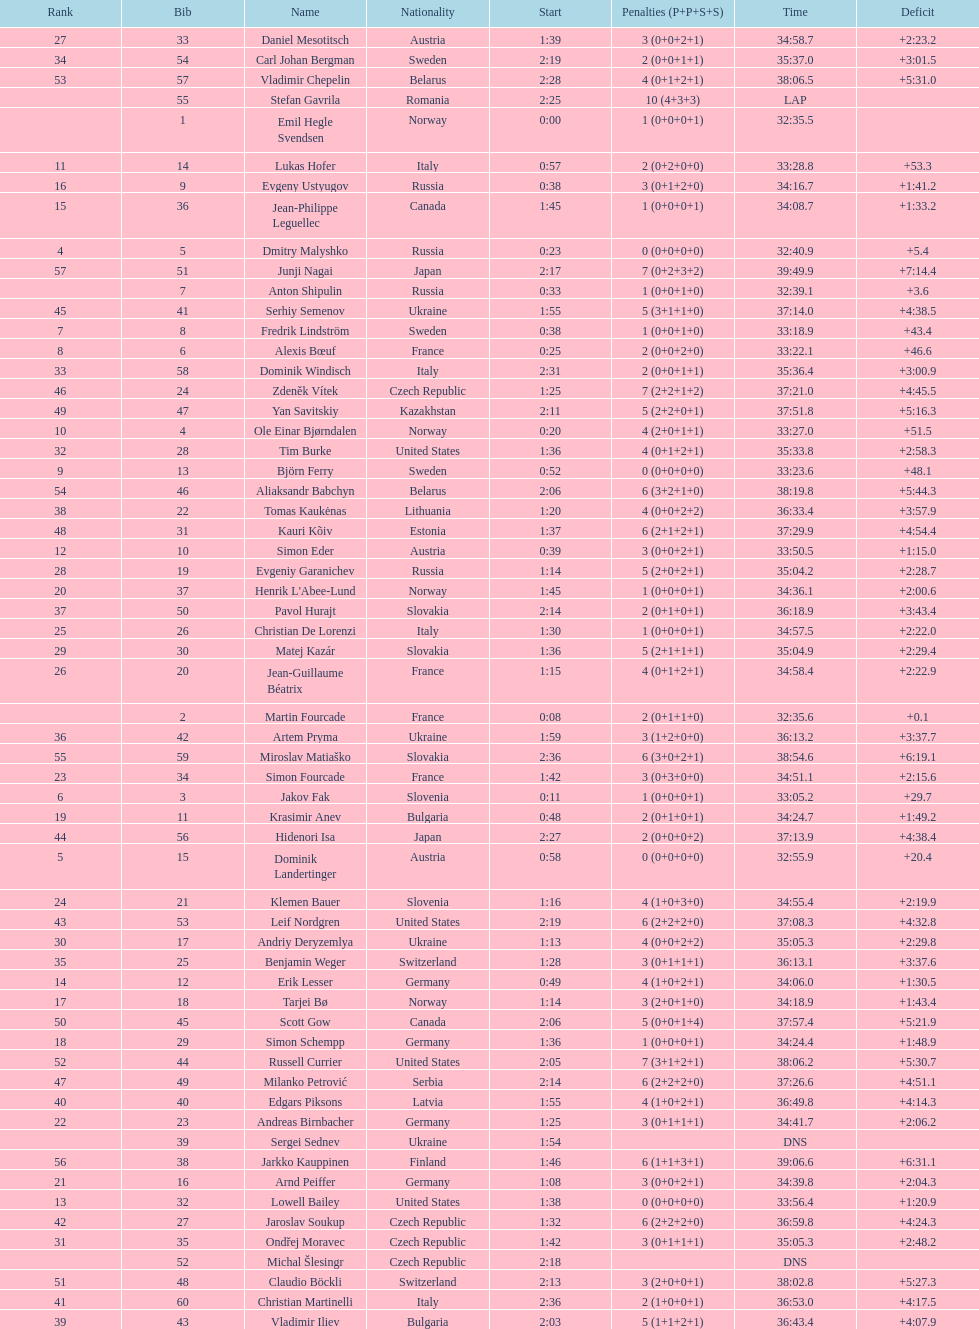How many penalties did germany get all together? 11. 